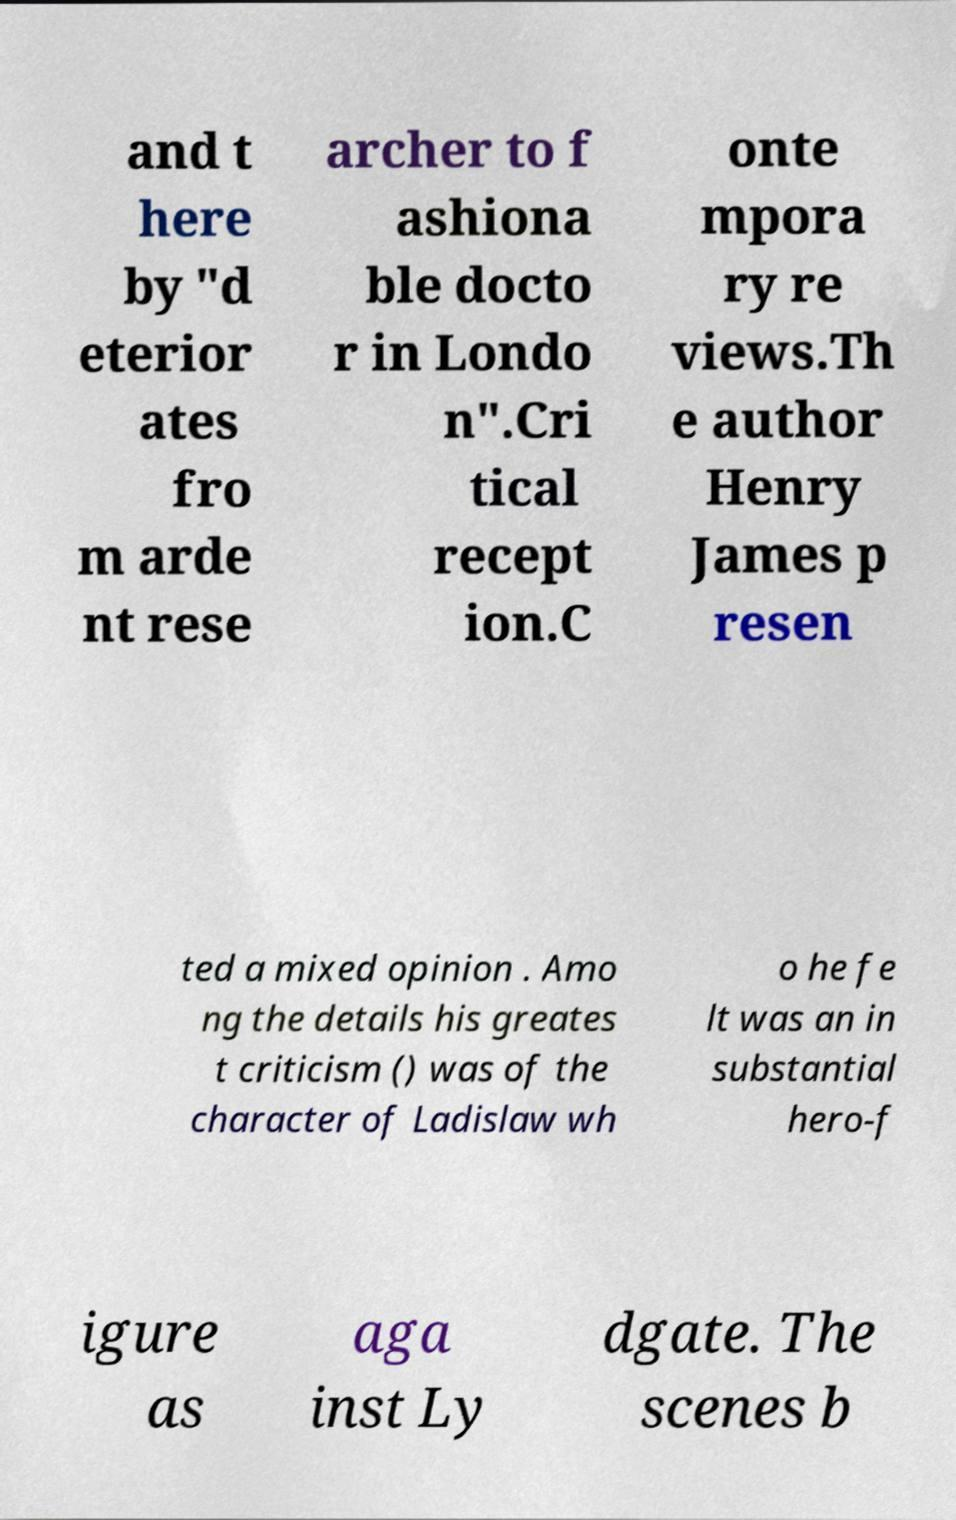Please read and relay the text visible in this image. What does it say? and t here by "d eterior ates fro m arde nt rese archer to f ashiona ble docto r in Londo n".Cri tical recept ion.C onte mpora ry re views.Th e author Henry James p resen ted a mixed opinion . Amo ng the details his greates t criticism () was of the character of Ladislaw wh o he fe lt was an in substantial hero-f igure as aga inst Ly dgate. The scenes b 